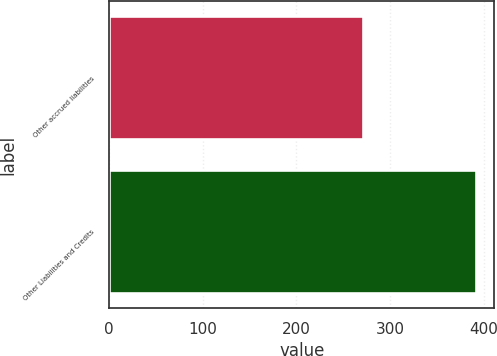<chart> <loc_0><loc_0><loc_500><loc_500><bar_chart><fcel>Other accrued liabilities<fcel>Other Liabilities and Credits<nl><fcel>271<fcel>392<nl></chart> 